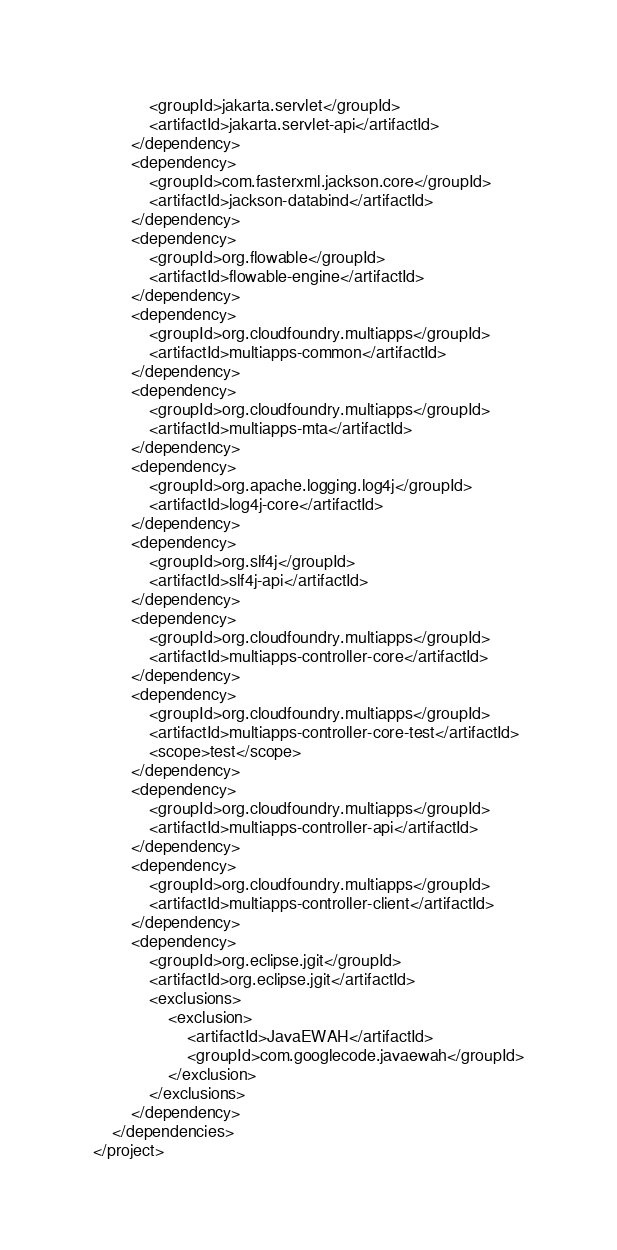Convert code to text. <code><loc_0><loc_0><loc_500><loc_500><_XML_>            <groupId>jakarta.servlet</groupId>
            <artifactId>jakarta.servlet-api</artifactId>
        </dependency>
        <dependency>
            <groupId>com.fasterxml.jackson.core</groupId>
            <artifactId>jackson-databind</artifactId>
        </dependency>
        <dependency>
            <groupId>org.flowable</groupId>
            <artifactId>flowable-engine</artifactId>
        </dependency>
        <dependency>
            <groupId>org.cloudfoundry.multiapps</groupId>
            <artifactId>multiapps-common</artifactId>
        </dependency>
        <dependency>
            <groupId>org.cloudfoundry.multiapps</groupId>
            <artifactId>multiapps-mta</artifactId>
        </dependency>
        <dependency>
            <groupId>org.apache.logging.log4j</groupId>
            <artifactId>log4j-core</artifactId>
        </dependency>
        <dependency>
            <groupId>org.slf4j</groupId>
            <artifactId>slf4j-api</artifactId>
        </dependency>
        <dependency>
            <groupId>org.cloudfoundry.multiapps</groupId>
            <artifactId>multiapps-controller-core</artifactId>
        </dependency>
        <dependency>
            <groupId>org.cloudfoundry.multiapps</groupId>
            <artifactId>multiapps-controller-core-test</artifactId>
            <scope>test</scope>
        </dependency>
        <dependency>
            <groupId>org.cloudfoundry.multiapps</groupId>
            <artifactId>multiapps-controller-api</artifactId>
        </dependency>
        <dependency>
            <groupId>org.cloudfoundry.multiapps</groupId>
            <artifactId>multiapps-controller-client</artifactId>
        </dependency>
        <dependency>
            <groupId>org.eclipse.jgit</groupId>
            <artifactId>org.eclipse.jgit</artifactId>
            <exclusions>
                <exclusion>
                    <artifactId>JavaEWAH</artifactId>
                    <groupId>com.googlecode.javaewah</groupId>
                </exclusion>
            </exclusions>
        </dependency>
    </dependencies>
</project></code> 